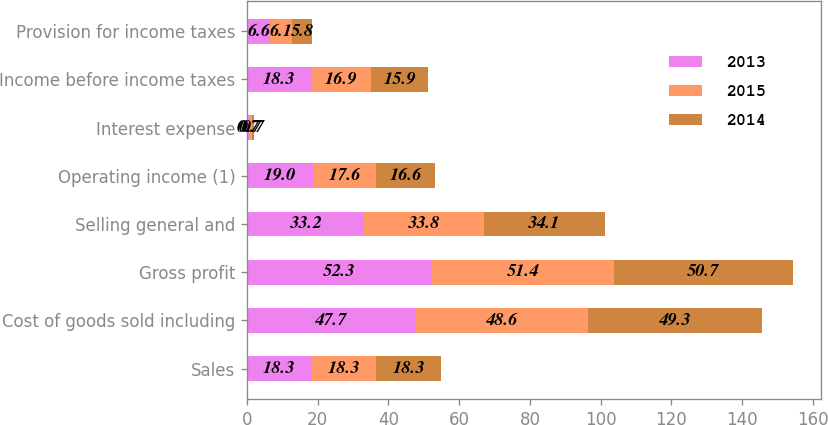Convert chart to OTSL. <chart><loc_0><loc_0><loc_500><loc_500><stacked_bar_chart><ecel><fcel>Sales<fcel>Cost of goods sold including<fcel>Gross profit<fcel>Selling general and<fcel>Operating income (1)<fcel>Interest expense<fcel>Income before income taxes<fcel>Provision for income taxes<nl><fcel>2013<fcel>18.3<fcel>47.7<fcel>52.3<fcel>33.2<fcel>19<fcel>0.7<fcel>18.3<fcel>6.6<nl><fcel>2015<fcel>18.3<fcel>48.6<fcel>51.4<fcel>33.8<fcel>17.6<fcel>0.7<fcel>16.9<fcel>6.1<nl><fcel>2014<fcel>18.3<fcel>49.3<fcel>50.7<fcel>34.1<fcel>16.6<fcel>0.7<fcel>15.9<fcel>5.8<nl></chart> 